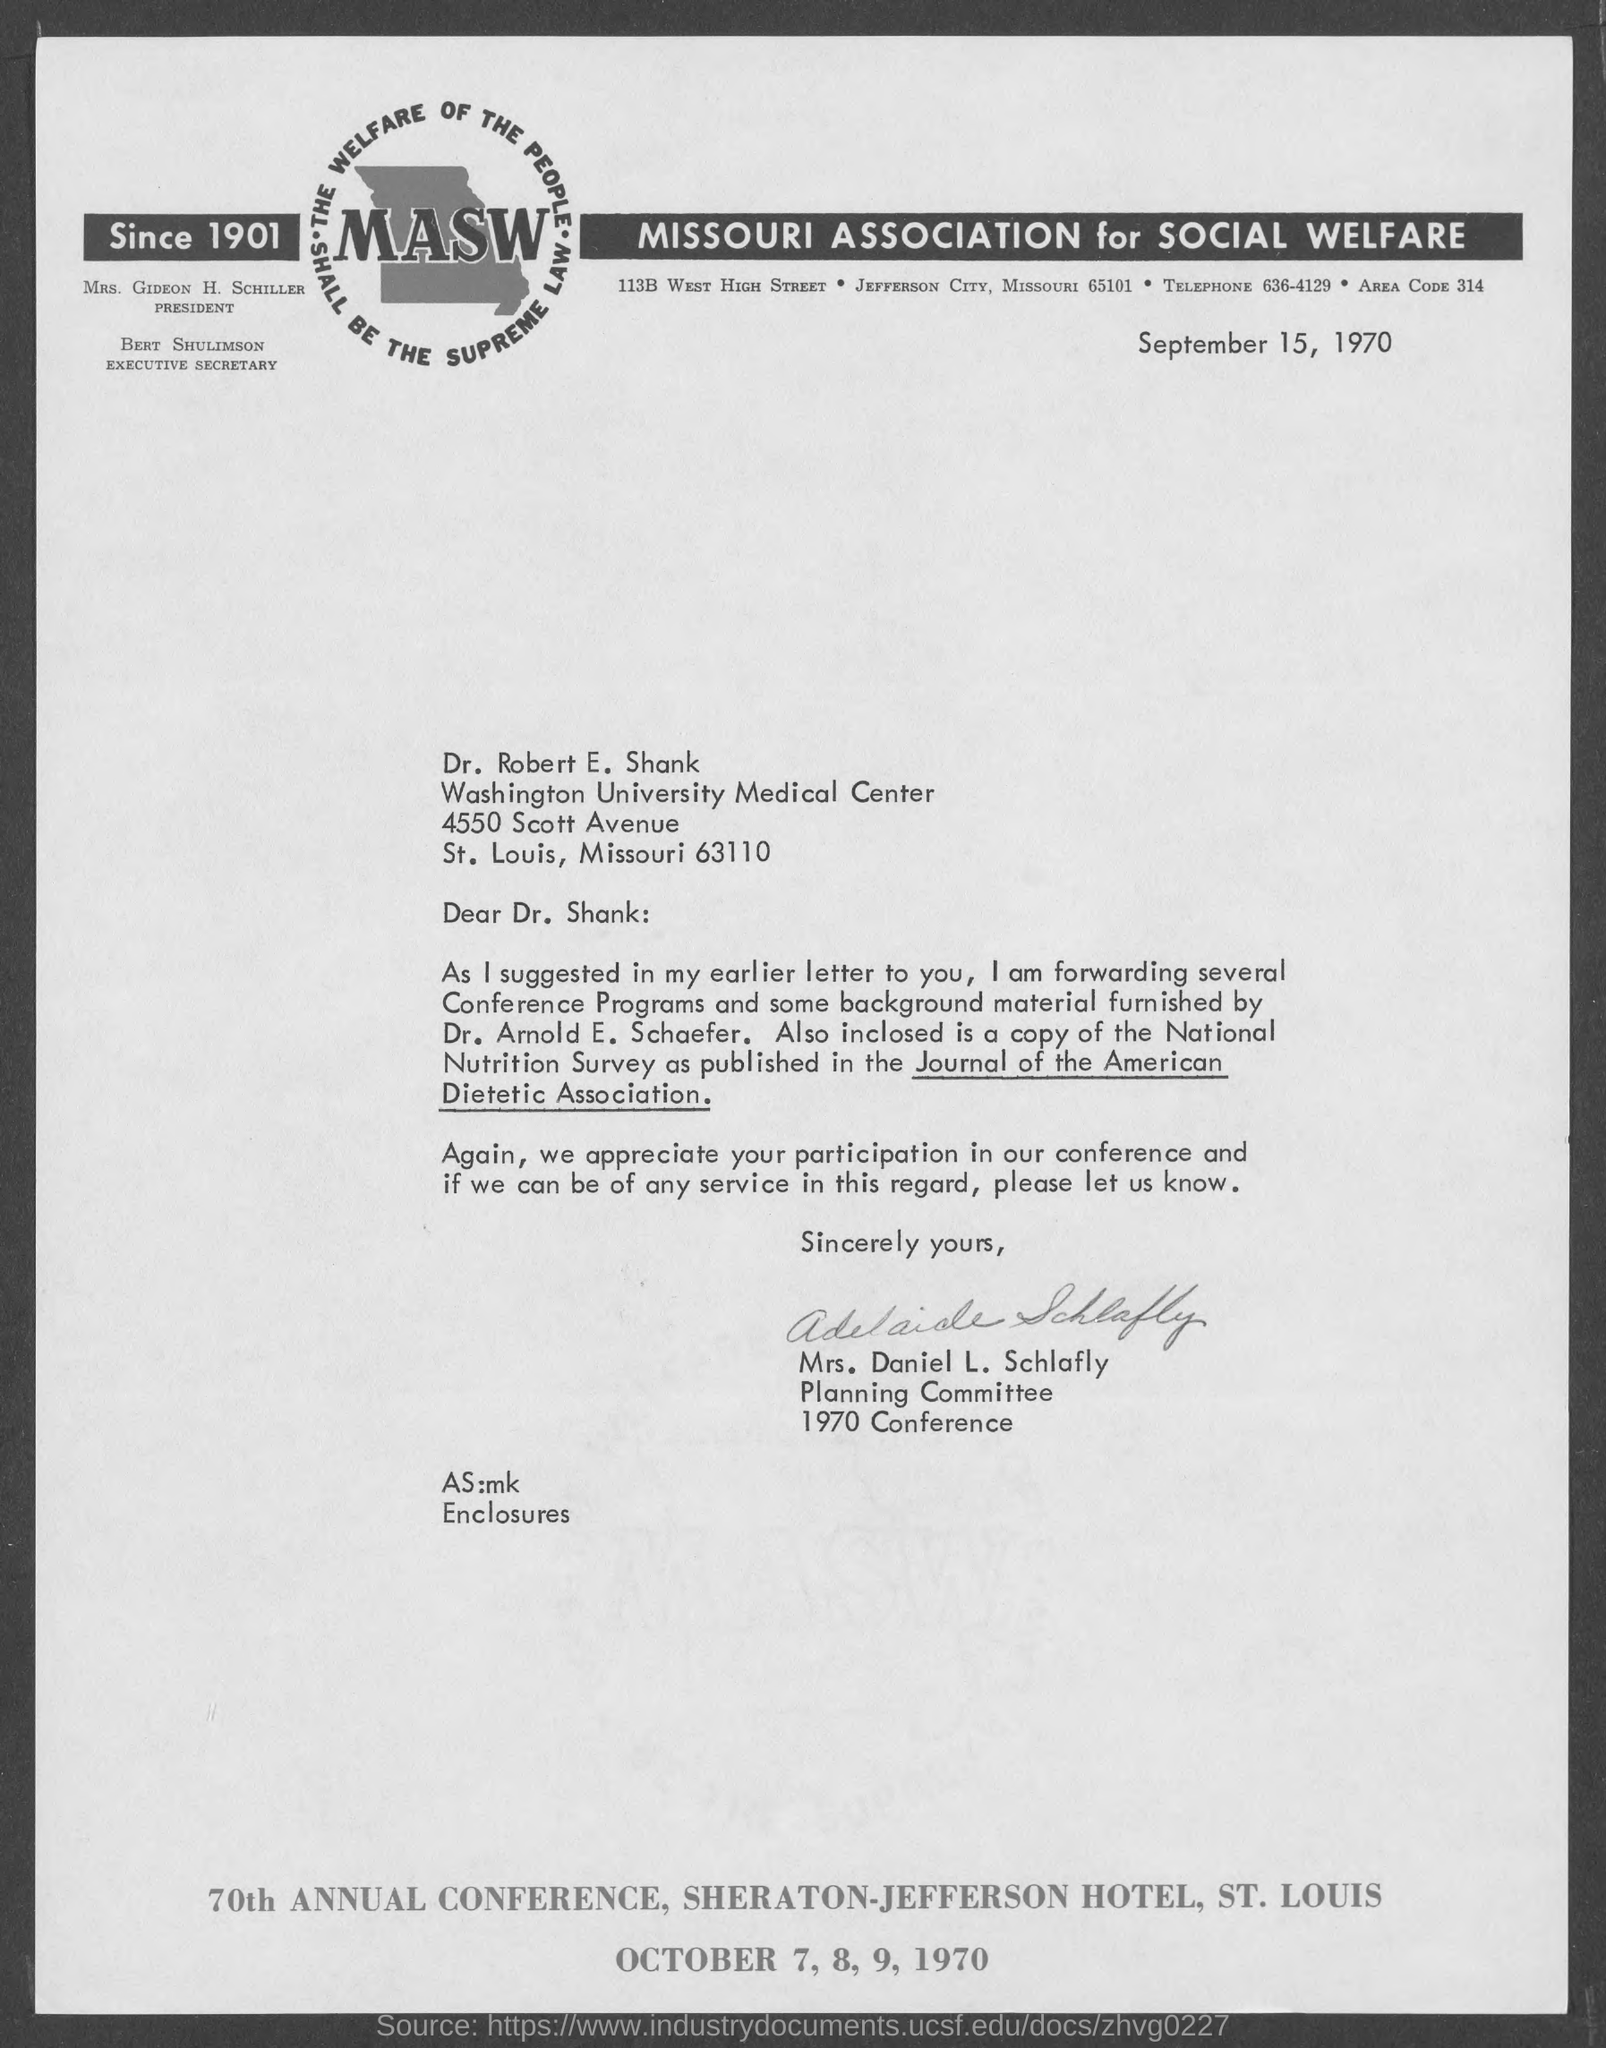Point out several critical features in this image. This letter is addressed to Dr. Robert E. Shank. 